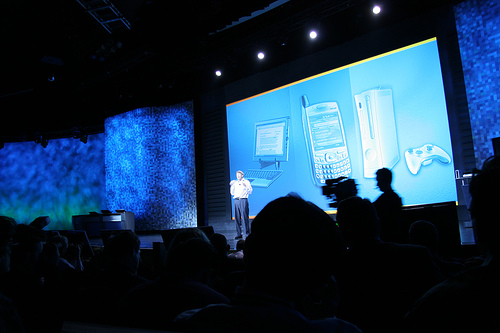<image>
Is the man in the screen? No. The man is not contained within the screen. These objects have a different spatial relationship. 